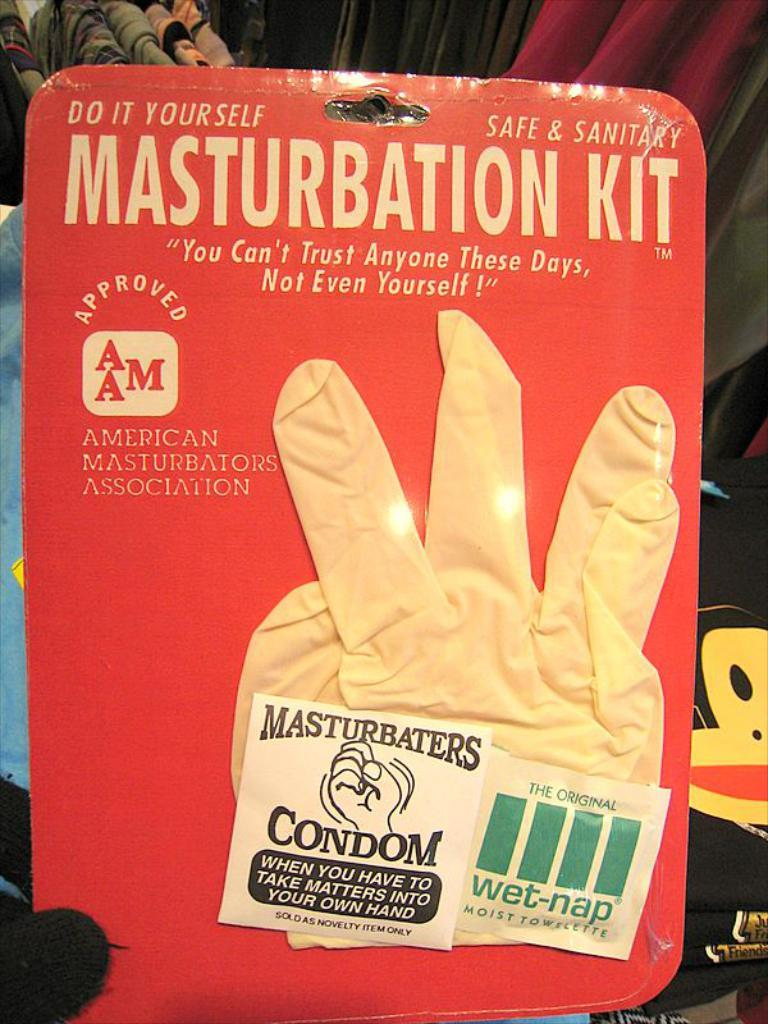What is the main object in the center of the image? There is a packet in the center of the image. What is inside the packet? The packet contains gloves. Is there any text on the packet? Yes, there is text on the packet. What can be seen in the background of the image? There are clothes and a bag in the background of the image. What type of glass can be seen in the image? There is no glass present in the image. Can you describe the taste of the gloves in the packet? The gloves in the packet do not have a taste, as they are not edible. 